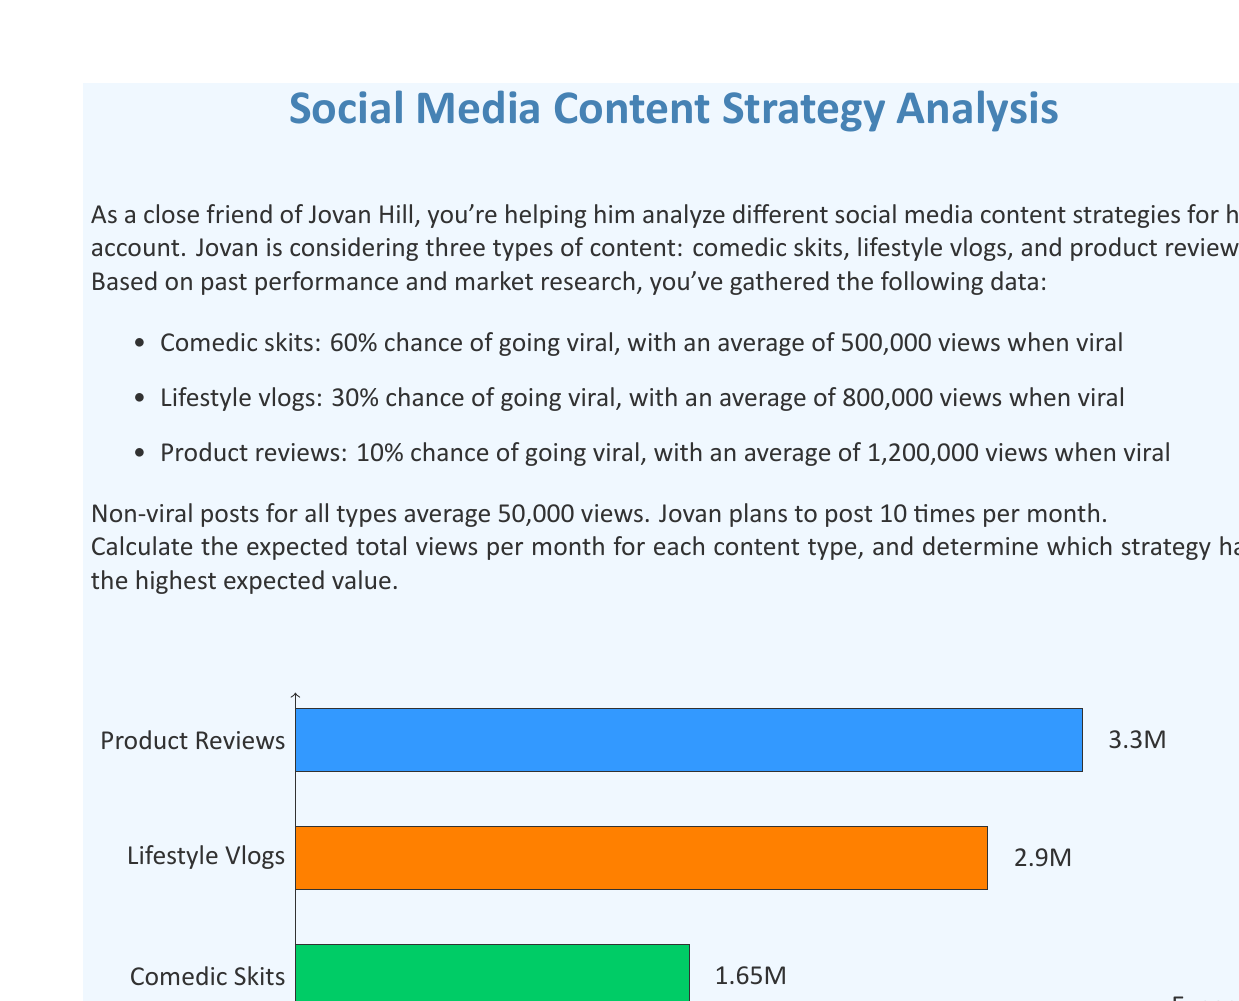Solve this math problem. Let's break this down step-by-step:

1) First, we need to calculate the expected views for a single post of each type:

   a) Comedic skits:
      $E(\text{views}) = 0.60 \times 500,000 + 0.40 \times 50,000$
      $= 300,000 + 20,000 = 320,000$

   b) Lifestyle vlogs:
      $E(\text{views}) = 0.30 \times 800,000 + 0.70 \times 50,000$
      $= 240,000 + 35,000 = 275,000$

   c) Product reviews:
      $E(\text{views}) = 0.10 \times 1,200,000 + 0.90 \times 50,000$
      $= 120,000 + 45,000 = 165,000$

2) Now, we need to multiply these expected views by the number of posts per month (10):

   a) Comedic skits: $320,000 \times 10 = 3,200,000$
   b) Lifestyle vlogs: $275,000 \times 10 = 2,750,000$
   c) Product reviews: $165,000 \times 10 = 1,650,000$

3) Comparing the results:
   Comedic skits have the highest expected value at 3.2 million views per month.
   Lifestyle vlogs come second with 2.75 million views per month.
   Product reviews have the lowest expected value at 1.65 million views per month.

Therefore, based on expected value, the comedic skits strategy has the highest expected value and would be the recommended approach for maximizing views.
Answer: Comedic skits: 3,200,000 views/month (highest EV) 